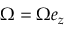Convert formula to latex. <formula><loc_0><loc_0><loc_500><loc_500>\Omega = \Omega e _ { z }</formula> 